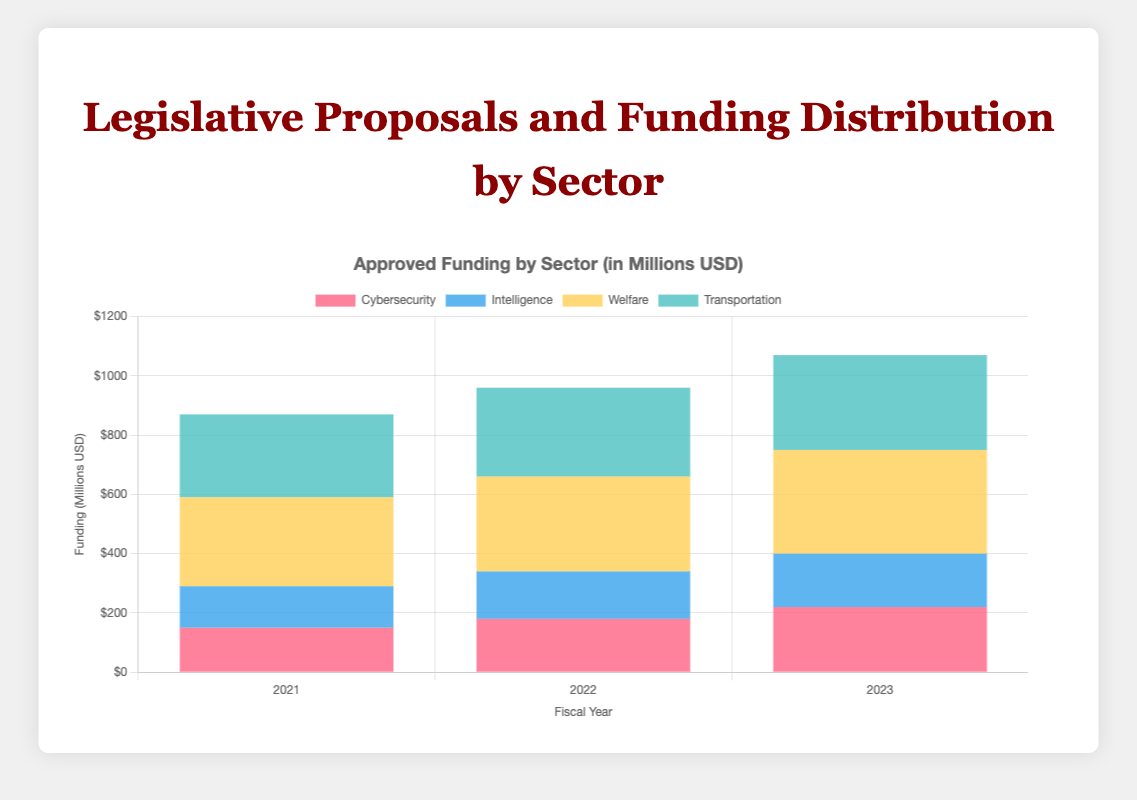What's the total approved funding for Cybersecurity in 2022 and 2023? First, find the approved funding for Cybersecurity in 2022, which is 180 million. Then find the approved funding for 2023, which is 220 million. Add these two values together: 180 + 220 = 400 million.
Answer: 400 million Which sector received the highest approved funding in 2021? Compare the approved funding for all sectors in 2021: Cybersecurity (150 million), Intelligence (140 million), Welfare (300 million), Transportation (280 million). The highest value is in the Welfare sector, which is 300 million.
Answer: Welfare What is the difference in approved funding between Cybersecurity and Welfare in 2023? Find the approved funding for Cybersecurity in 2023, which is 220 million, and for Welfare, which is 350 million. Subtract the Cybersecurity funding from the Welfare funding: 350 - 220 = 130 million.
Answer: 130 million How does the trend in approved funding for Intelligence compare to Welfare from 2021 to 2023? Find the approved funding for Intelligence over three years: 140 million (2021), 160 million (2022), 180 million (2023). For Welfare: 300 million (2021), 320 million (2022), 350 million (2023). Intelligence funding increased steadily from 140 to 160 to 180 million, while Welfare funding also increased steadily but with higher magnitudes from 300 to 320 to 350 million.
Answer: Intelligence and Welfare both increased steadily; Welfare had higher increments Which sector had the smallest increase in approved funding from 2021 to 2023? Find the approved funding for each sector in 2021 and 2023: Cybersecurity (150 to 220 million), Intelligence (140 to 180 million), Welfare (300 to 350 million), Transportation (280 to 320 million). Calculate the increase for each sector: Cybersecurity (70 million), Intelligence (40 million), Welfare (50 million), Transportation (40 million). The smallest increase is for Intelligence and Transportation (both 40 million).
Answer: Intelligence and Transportation What is the average approved funding per year for the Transportation sector over the three years? Add up the approved funding for the Transportation sector from 2021 to 2023: 280 million (2021) + 300 million (2022) + 320 million (2023) = 900 million. Divide by the number of years (3): 900 / 3 = 300 million.
Answer: 300 million Compare the approved funding of Cybersecurity and Intelligence in 2022. Which one had more, and by how much? Find the approved funding for Cybersecurity in 2022, which is 180 million, and for Intelligence, which is 160 million. Subtract the Intelligence funding from the Cybersecurity funding to get the difference: 180 - 160 = 20 million. Cybersecurity had more funding.
Answer: Cybersecurity by 20 million What sector had a constant trend in the number of proposals approved from 2021 to 2023? Review the number of proposals approved for each sector across the three years. Cybersecurity (30, 35, 40), Intelligence (25, 30, 35), Welfare (60, 65, 70), Transportation (50, 55, 60). None of the sectors had a constant trend; all showed an increasing trend.
Answer: None Which fiscal year had the highest total approved funding across all sectors? Sum the approved funding for all sectors in each fiscal year: 
2021: 150 (Cybersecurity) + 140 (Intelligence) + 300 (Welfare) + 280 (Transportation) = 870 million.
2022: 180 (Cybersecurity) + 160 (Intelligence) + 320 (Welfare) + 300 (Transportation) = 960 million.
2023: 220 (Cybersecurity) + 180 (Intelligence) + 350 (Welfare) + 320 (Transportation) = 1070 million. 
The highest total is in 2023 with 1070 million.
Answer: 2023 